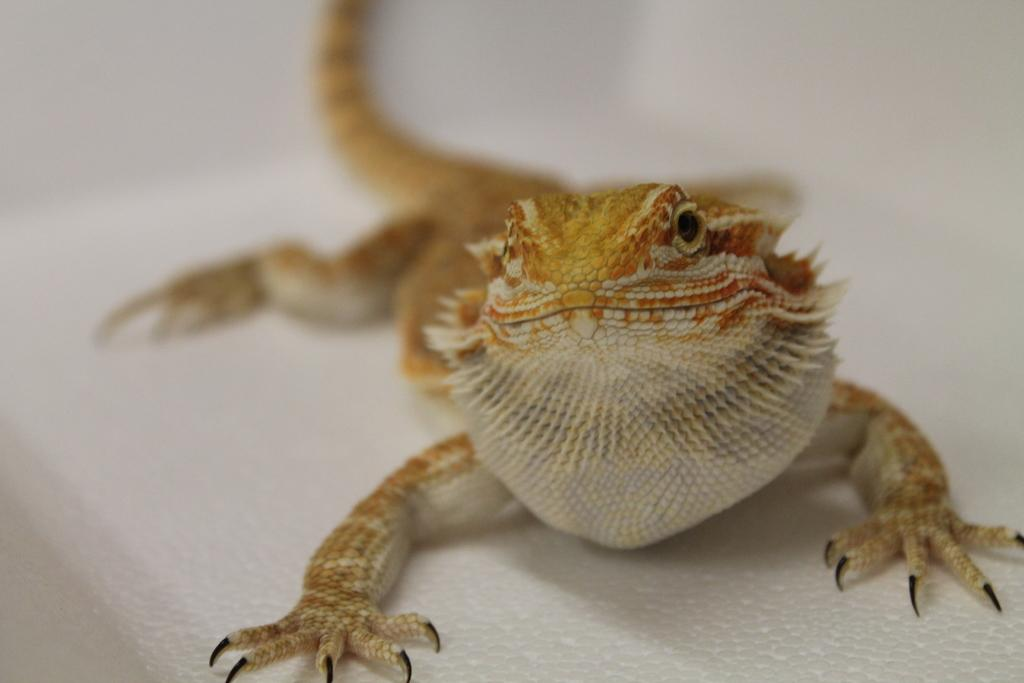What type of animal is in the image? There is a reptile in the image. Can you describe the coloration of the reptile? The reptile has brown and cream coloration. What is the background or surface on which the reptile is situated? The reptile is on a white surface. What type of locket is the reptile wearing in the image? There is no locket present in the image, as it features a reptile on a white surface. 